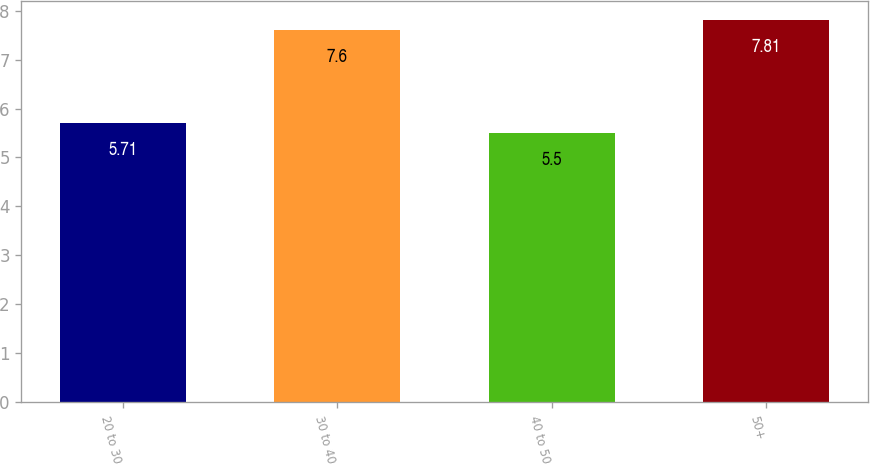<chart> <loc_0><loc_0><loc_500><loc_500><bar_chart><fcel>20 to 30<fcel>30 to 40<fcel>40 to 50<fcel>50+<nl><fcel>5.71<fcel>7.6<fcel>5.5<fcel>7.81<nl></chart> 